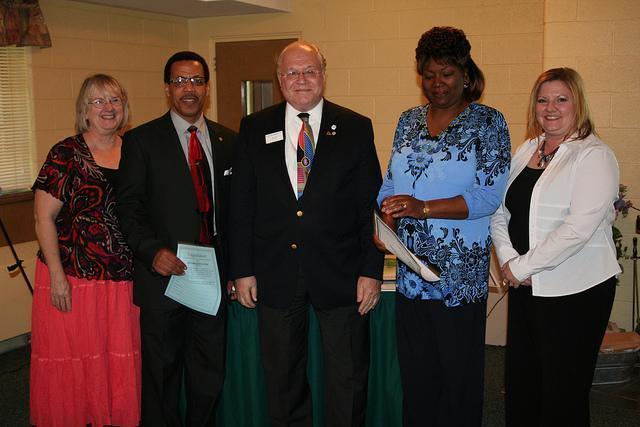How many men are in this picture?
Give a very brief answer. 2. How many women are in the picture?
Give a very brief answer. 3. How many white person do you see?
Give a very brief answer. 3. How many people are in the photo?
Give a very brief answer. 5. 